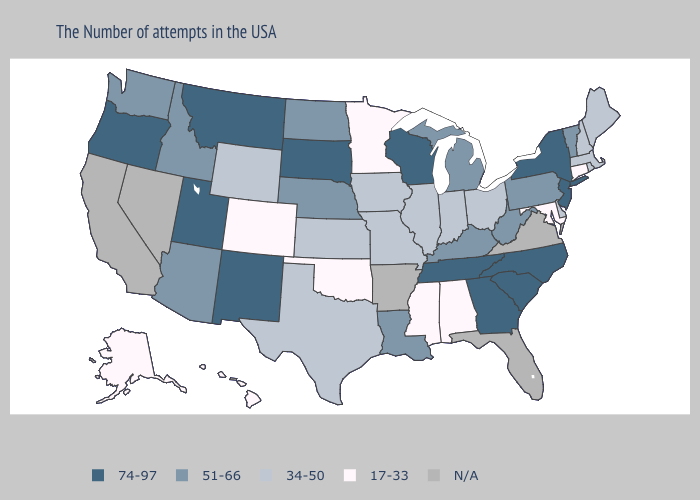What is the value of Iowa?
Answer briefly. 34-50. Among the states that border Ohio , which have the highest value?
Keep it brief. Pennsylvania, West Virginia, Michigan, Kentucky. What is the value of Oklahoma?
Concise answer only. 17-33. Does the map have missing data?
Quick response, please. Yes. Name the states that have a value in the range 34-50?
Answer briefly. Maine, Massachusetts, Rhode Island, New Hampshire, Delaware, Ohio, Indiana, Illinois, Missouri, Iowa, Kansas, Texas, Wyoming. Name the states that have a value in the range 51-66?
Answer briefly. Vermont, Pennsylvania, West Virginia, Michigan, Kentucky, Louisiana, Nebraska, North Dakota, Arizona, Idaho, Washington. What is the value of Montana?
Keep it brief. 74-97. How many symbols are there in the legend?
Short answer required. 5. Which states have the lowest value in the Northeast?
Keep it brief. Connecticut. What is the highest value in the USA?
Be succinct. 74-97. 